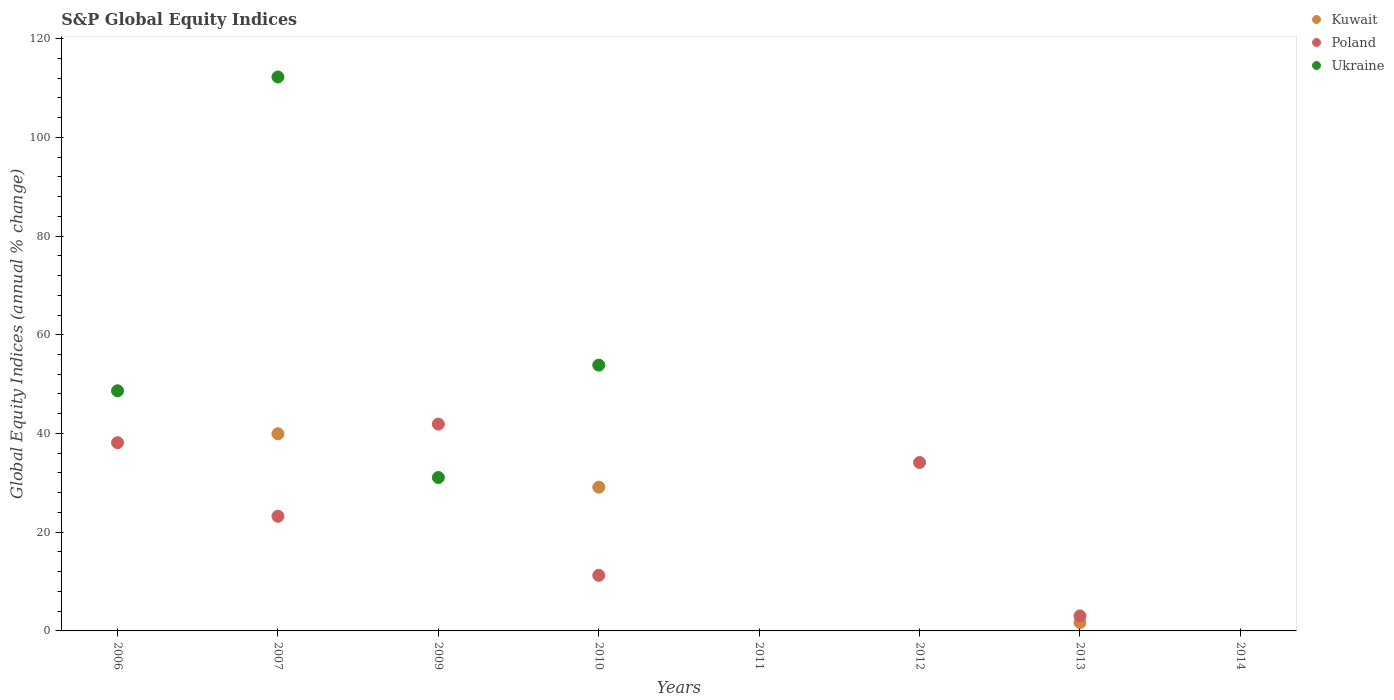What is the global equity indices in Poland in 2012?
Keep it short and to the point. 34.12. Across all years, what is the maximum global equity indices in Poland?
Offer a terse response. 41.9. In which year was the global equity indices in Ukraine maximum?
Your answer should be compact. 2007. What is the total global equity indices in Kuwait in the graph?
Offer a very short reply. 70.76. What is the difference between the global equity indices in Poland in 2009 and that in 2013?
Make the answer very short. 38.86. What is the difference between the global equity indices in Poland in 2011 and the global equity indices in Kuwait in 2012?
Offer a terse response. 0. What is the average global equity indices in Kuwait per year?
Provide a short and direct response. 8.85. In the year 2007, what is the difference between the global equity indices in Poland and global equity indices in Ukraine?
Offer a terse response. -89. In how many years, is the global equity indices in Kuwait greater than 76 %?
Give a very brief answer. 0. What is the ratio of the global equity indices in Poland in 2006 to that in 2010?
Provide a succinct answer. 3.39. What is the difference between the highest and the second highest global equity indices in Ukraine?
Ensure brevity in your answer.  58.38. What is the difference between the highest and the lowest global equity indices in Poland?
Your answer should be very brief. 41.9. Is it the case that in every year, the sum of the global equity indices in Ukraine and global equity indices in Kuwait  is greater than the global equity indices in Poland?
Keep it short and to the point. No. Does the global equity indices in Ukraine monotonically increase over the years?
Offer a terse response. No. How many dotlines are there?
Provide a short and direct response. 3. How many years are there in the graph?
Your answer should be compact. 8. Are the values on the major ticks of Y-axis written in scientific E-notation?
Provide a succinct answer. No. Does the graph contain grids?
Give a very brief answer. No. How are the legend labels stacked?
Keep it short and to the point. Vertical. What is the title of the graph?
Make the answer very short. S&P Global Equity Indices. What is the label or title of the X-axis?
Offer a terse response. Years. What is the label or title of the Y-axis?
Your response must be concise. Global Equity Indices (annual % change). What is the Global Equity Indices (annual % change) of Poland in 2006?
Offer a terse response. 38.13. What is the Global Equity Indices (annual % change) in Ukraine in 2006?
Provide a succinct answer. 48.65. What is the Global Equity Indices (annual % change) in Kuwait in 2007?
Ensure brevity in your answer.  39.94. What is the Global Equity Indices (annual % change) of Poland in 2007?
Offer a very short reply. 23.22. What is the Global Equity Indices (annual % change) of Ukraine in 2007?
Your response must be concise. 112.22. What is the Global Equity Indices (annual % change) of Poland in 2009?
Your answer should be very brief. 41.9. What is the Global Equity Indices (annual % change) in Ukraine in 2009?
Your answer should be compact. 31.08. What is the Global Equity Indices (annual % change) of Kuwait in 2010?
Give a very brief answer. 29.12. What is the Global Equity Indices (annual % change) in Poland in 2010?
Keep it short and to the point. 11.26. What is the Global Equity Indices (annual % change) of Ukraine in 2010?
Your answer should be compact. 53.84. What is the Global Equity Indices (annual % change) in Poland in 2012?
Offer a terse response. 34.12. What is the Global Equity Indices (annual % change) of Kuwait in 2013?
Offer a very short reply. 1.7. What is the Global Equity Indices (annual % change) of Poland in 2013?
Your answer should be compact. 3.04. What is the Global Equity Indices (annual % change) of Ukraine in 2013?
Offer a very short reply. 0. What is the Global Equity Indices (annual % change) in Kuwait in 2014?
Your answer should be compact. 0. What is the Global Equity Indices (annual % change) of Poland in 2014?
Ensure brevity in your answer.  0. Across all years, what is the maximum Global Equity Indices (annual % change) of Kuwait?
Provide a short and direct response. 39.94. Across all years, what is the maximum Global Equity Indices (annual % change) in Poland?
Offer a terse response. 41.9. Across all years, what is the maximum Global Equity Indices (annual % change) in Ukraine?
Offer a terse response. 112.22. Across all years, what is the minimum Global Equity Indices (annual % change) in Kuwait?
Your answer should be compact. 0. Across all years, what is the minimum Global Equity Indices (annual % change) in Ukraine?
Give a very brief answer. 0. What is the total Global Equity Indices (annual % change) in Kuwait in the graph?
Your response must be concise. 70.76. What is the total Global Equity Indices (annual % change) in Poland in the graph?
Keep it short and to the point. 151.67. What is the total Global Equity Indices (annual % change) of Ukraine in the graph?
Keep it short and to the point. 245.79. What is the difference between the Global Equity Indices (annual % change) in Poland in 2006 and that in 2007?
Offer a terse response. 14.91. What is the difference between the Global Equity Indices (annual % change) of Ukraine in 2006 and that in 2007?
Give a very brief answer. -63.57. What is the difference between the Global Equity Indices (annual % change) of Poland in 2006 and that in 2009?
Ensure brevity in your answer.  -3.77. What is the difference between the Global Equity Indices (annual % change) in Ukraine in 2006 and that in 2009?
Give a very brief answer. 17.57. What is the difference between the Global Equity Indices (annual % change) in Poland in 2006 and that in 2010?
Make the answer very short. 26.87. What is the difference between the Global Equity Indices (annual % change) in Ukraine in 2006 and that in 2010?
Ensure brevity in your answer.  -5.2. What is the difference between the Global Equity Indices (annual % change) in Poland in 2006 and that in 2012?
Your answer should be compact. 4.01. What is the difference between the Global Equity Indices (annual % change) in Poland in 2006 and that in 2013?
Offer a terse response. 35.09. What is the difference between the Global Equity Indices (annual % change) in Poland in 2007 and that in 2009?
Give a very brief answer. -18.68. What is the difference between the Global Equity Indices (annual % change) in Ukraine in 2007 and that in 2009?
Provide a succinct answer. 81.14. What is the difference between the Global Equity Indices (annual % change) in Kuwait in 2007 and that in 2010?
Provide a short and direct response. 10.81. What is the difference between the Global Equity Indices (annual % change) in Poland in 2007 and that in 2010?
Offer a terse response. 11.96. What is the difference between the Global Equity Indices (annual % change) of Ukraine in 2007 and that in 2010?
Provide a succinct answer. 58.38. What is the difference between the Global Equity Indices (annual % change) of Poland in 2007 and that in 2012?
Your response must be concise. -10.9. What is the difference between the Global Equity Indices (annual % change) of Kuwait in 2007 and that in 2013?
Offer a terse response. 38.24. What is the difference between the Global Equity Indices (annual % change) of Poland in 2007 and that in 2013?
Keep it short and to the point. 20.19. What is the difference between the Global Equity Indices (annual % change) of Poland in 2009 and that in 2010?
Provide a succinct answer. 30.64. What is the difference between the Global Equity Indices (annual % change) of Ukraine in 2009 and that in 2010?
Offer a terse response. -22.77. What is the difference between the Global Equity Indices (annual % change) of Poland in 2009 and that in 2012?
Ensure brevity in your answer.  7.78. What is the difference between the Global Equity Indices (annual % change) of Poland in 2009 and that in 2013?
Give a very brief answer. 38.86. What is the difference between the Global Equity Indices (annual % change) of Poland in 2010 and that in 2012?
Your answer should be very brief. -22.86. What is the difference between the Global Equity Indices (annual % change) of Kuwait in 2010 and that in 2013?
Provide a succinct answer. 27.43. What is the difference between the Global Equity Indices (annual % change) in Poland in 2010 and that in 2013?
Your response must be concise. 8.22. What is the difference between the Global Equity Indices (annual % change) in Poland in 2012 and that in 2013?
Offer a terse response. 31.09. What is the difference between the Global Equity Indices (annual % change) in Poland in 2006 and the Global Equity Indices (annual % change) in Ukraine in 2007?
Keep it short and to the point. -74.09. What is the difference between the Global Equity Indices (annual % change) of Poland in 2006 and the Global Equity Indices (annual % change) of Ukraine in 2009?
Give a very brief answer. 7.05. What is the difference between the Global Equity Indices (annual % change) of Poland in 2006 and the Global Equity Indices (annual % change) of Ukraine in 2010?
Provide a short and direct response. -15.71. What is the difference between the Global Equity Indices (annual % change) of Kuwait in 2007 and the Global Equity Indices (annual % change) of Poland in 2009?
Ensure brevity in your answer.  -1.96. What is the difference between the Global Equity Indices (annual % change) in Kuwait in 2007 and the Global Equity Indices (annual % change) in Ukraine in 2009?
Provide a short and direct response. 8.86. What is the difference between the Global Equity Indices (annual % change) in Poland in 2007 and the Global Equity Indices (annual % change) in Ukraine in 2009?
Make the answer very short. -7.85. What is the difference between the Global Equity Indices (annual % change) in Kuwait in 2007 and the Global Equity Indices (annual % change) in Poland in 2010?
Provide a succinct answer. 28.68. What is the difference between the Global Equity Indices (annual % change) in Kuwait in 2007 and the Global Equity Indices (annual % change) in Ukraine in 2010?
Provide a succinct answer. -13.9. What is the difference between the Global Equity Indices (annual % change) of Poland in 2007 and the Global Equity Indices (annual % change) of Ukraine in 2010?
Your answer should be compact. -30.62. What is the difference between the Global Equity Indices (annual % change) in Kuwait in 2007 and the Global Equity Indices (annual % change) in Poland in 2012?
Provide a succinct answer. 5.82. What is the difference between the Global Equity Indices (annual % change) of Kuwait in 2007 and the Global Equity Indices (annual % change) of Poland in 2013?
Your answer should be compact. 36.9. What is the difference between the Global Equity Indices (annual % change) in Poland in 2009 and the Global Equity Indices (annual % change) in Ukraine in 2010?
Keep it short and to the point. -11.94. What is the difference between the Global Equity Indices (annual % change) of Kuwait in 2010 and the Global Equity Indices (annual % change) of Poland in 2012?
Offer a terse response. -5. What is the difference between the Global Equity Indices (annual % change) of Kuwait in 2010 and the Global Equity Indices (annual % change) of Poland in 2013?
Keep it short and to the point. 26.09. What is the average Global Equity Indices (annual % change) of Kuwait per year?
Ensure brevity in your answer.  8.85. What is the average Global Equity Indices (annual % change) of Poland per year?
Your response must be concise. 18.96. What is the average Global Equity Indices (annual % change) of Ukraine per year?
Keep it short and to the point. 30.72. In the year 2006, what is the difference between the Global Equity Indices (annual % change) of Poland and Global Equity Indices (annual % change) of Ukraine?
Offer a terse response. -10.52. In the year 2007, what is the difference between the Global Equity Indices (annual % change) of Kuwait and Global Equity Indices (annual % change) of Poland?
Make the answer very short. 16.72. In the year 2007, what is the difference between the Global Equity Indices (annual % change) in Kuwait and Global Equity Indices (annual % change) in Ukraine?
Provide a short and direct response. -72.28. In the year 2007, what is the difference between the Global Equity Indices (annual % change) in Poland and Global Equity Indices (annual % change) in Ukraine?
Ensure brevity in your answer.  -89. In the year 2009, what is the difference between the Global Equity Indices (annual % change) of Poland and Global Equity Indices (annual % change) of Ukraine?
Offer a terse response. 10.82. In the year 2010, what is the difference between the Global Equity Indices (annual % change) of Kuwait and Global Equity Indices (annual % change) of Poland?
Keep it short and to the point. 17.86. In the year 2010, what is the difference between the Global Equity Indices (annual % change) in Kuwait and Global Equity Indices (annual % change) in Ukraine?
Keep it short and to the point. -24.72. In the year 2010, what is the difference between the Global Equity Indices (annual % change) in Poland and Global Equity Indices (annual % change) in Ukraine?
Your response must be concise. -42.58. In the year 2013, what is the difference between the Global Equity Indices (annual % change) in Kuwait and Global Equity Indices (annual % change) in Poland?
Offer a terse response. -1.34. What is the ratio of the Global Equity Indices (annual % change) in Poland in 2006 to that in 2007?
Offer a very short reply. 1.64. What is the ratio of the Global Equity Indices (annual % change) of Ukraine in 2006 to that in 2007?
Your answer should be compact. 0.43. What is the ratio of the Global Equity Indices (annual % change) in Poland in 2006 to that in 2009?
Give a very brief answer. 0.91. What is the ratio of the Global Equity Indices (annual % change) of Ukraine in 2006 to that in 2009?
Ensure brevity in your answer.  1.57. What is the ratio of the Global Equity Indices (annual % change) of Poland in 2006 to that in 2010?
Your answer should be very brief. 3.39. What is the ratio of the Global Equity Indices (annual % change) in Ukraine in 2006 to that in 2010?
Your answer should be compact. 0.9. What is the ratio of the Global Equity Indices (annual % change) in Poland in 2006 to that in 2012?
Make the answer very short. 1.12. What is the ratio of the Global Equity Indices (annual % change) in Poland in 2006 to that in 2013?
Your response must be concise. 12.56. What is the ratio of the Global Equity Indices (annual % change) of Poland in 2007 to that in 2009?
Your answer should be very brief. 0.55. What is the ratio of the Global Equity Indices (annual % change) in Ukraine in 2007 to that in 2009?
Keep it short and to the point. 3.61. What is the ratio of the Global Equity Indices (annual % change) of Kuwait in 2007 to that in 2010?
Ensure brevity in your answer.  1.37. What is the ratio of the Global Equity Indices (annual % change) of Poland in 2007 to that in 2010?
Make the answer very short. 2.06. What is the ratio of the Global Equity Indices (annual % change) of Ukraine in 2007 to that in 2010?
Offer a terse response. 2.08. What is the ratio of the Global Equity Indices (annual % change) of Poland in 2007 to that in 2012?
Offer a very short reply. 0.68. What is the ratio of the Global Equity Indices (annual % change) of Kuwait in 2007 to that in 2013?
Keep it short and to the point. 23.51. What is the ratio of the Global Equity Indices (annual % change) of Poland in 2007 to that in 2013?
Keep it short and to the point. 7.65. What is the ratio of the Global Equity Indices (annual % change) of Poland in 2009 to that in 2010?
Ensure brevity in your answer.  3.72. What is the ratio of the Global Equity Indices (annual % change) of Ukraine in 2009 to that in 2010?
Make the answer very short. 0.58. What is the ratio of the Global Equity Indices (annual % change) of Poland in 2009 to that in 2012?
Make the answer very short. 1.23. What is the ratio of the Global Equity Indices (annual % change) in Poland in 2009 to that in 2013?
Your response must be concise. 13.8. What is the ratio of the Global Equity Indices (annual % change) in Poland in 2010 to that in 2012?
Your response must be concise. 0.33. What is the ratio of the Global Equity Indices (annual % change) in Kuwait in 2010 to that in 2013?
Give a very brief answer. 17.15. What is the ratio of the Global Equity Indices (annual % change) of Poland in 2010 to that in 2013?
Make the answer very short. 3.71. What is the ratio of the Global Equity Indices (annual % change) in Poland in 2012 to that in 2013?
Offer a terse response. 11.24. What is the difference between the highest and the second highest Global Equity Indices (annual % change) of Kuwait?
Ensure brevity in your answer.  10.81. What is the difference between the highest and the second highest Global Equity Indices (annual % change) in Poland?
Give a very brief answer. 3.77. What is the difference between the highest and the second highest Global Equity Indices (annual % change) of Ukraine?
Offer a terse response. 58.38. What is the difference between the highest and the lowest Global Equity Indices (annual % change) of Kuwait?
Make the answer very short. 39.94. What is the difference between the highest and the lowest Global Equity Indices (annual % change) of Poland?
Offer a very short reply. 41.9. What is the difference between the highest and the lowest Global Equity Indices (annual % change) in Ukraine?
Your answer should be compact. 112.22. 